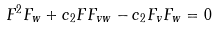<formula> <loc_0><loc_0><loc_500><loc_500>F ^ { 2 } F _ { w } + c _ { 2 } F F _ { v w } - c _ { 2 } F _ { v } F _ { w } = 0</formula> 